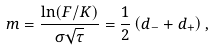<formula> <loc_0><loc_0><loc_500><loc_500>m = { \frac { \ln ( F / K ) } { \sigma { \sqrt { \tau } } } } = { \frac { 1 } { 2 } } \left ( d _ { - } + d _ { + } \right ) ,</formula> 